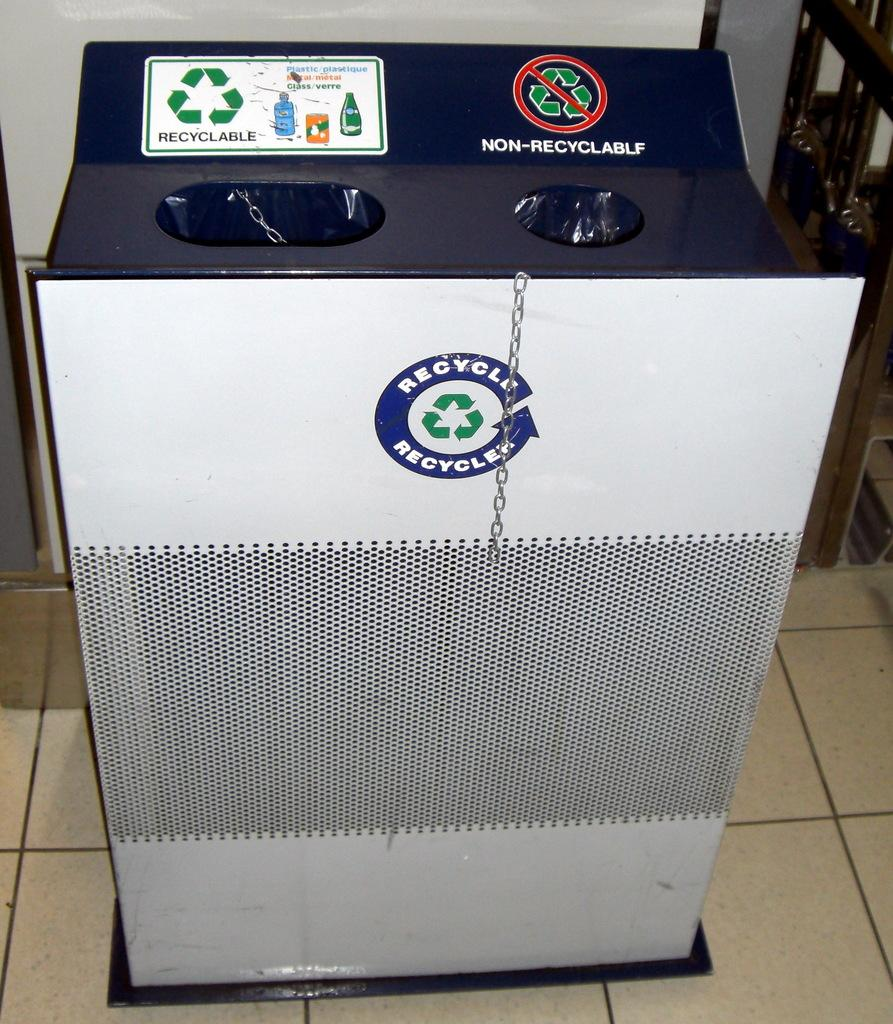<image>
Offer a succinct explanation of the picture presented. A recyclable bin that has two holes for both recyclable and non-recyclables 